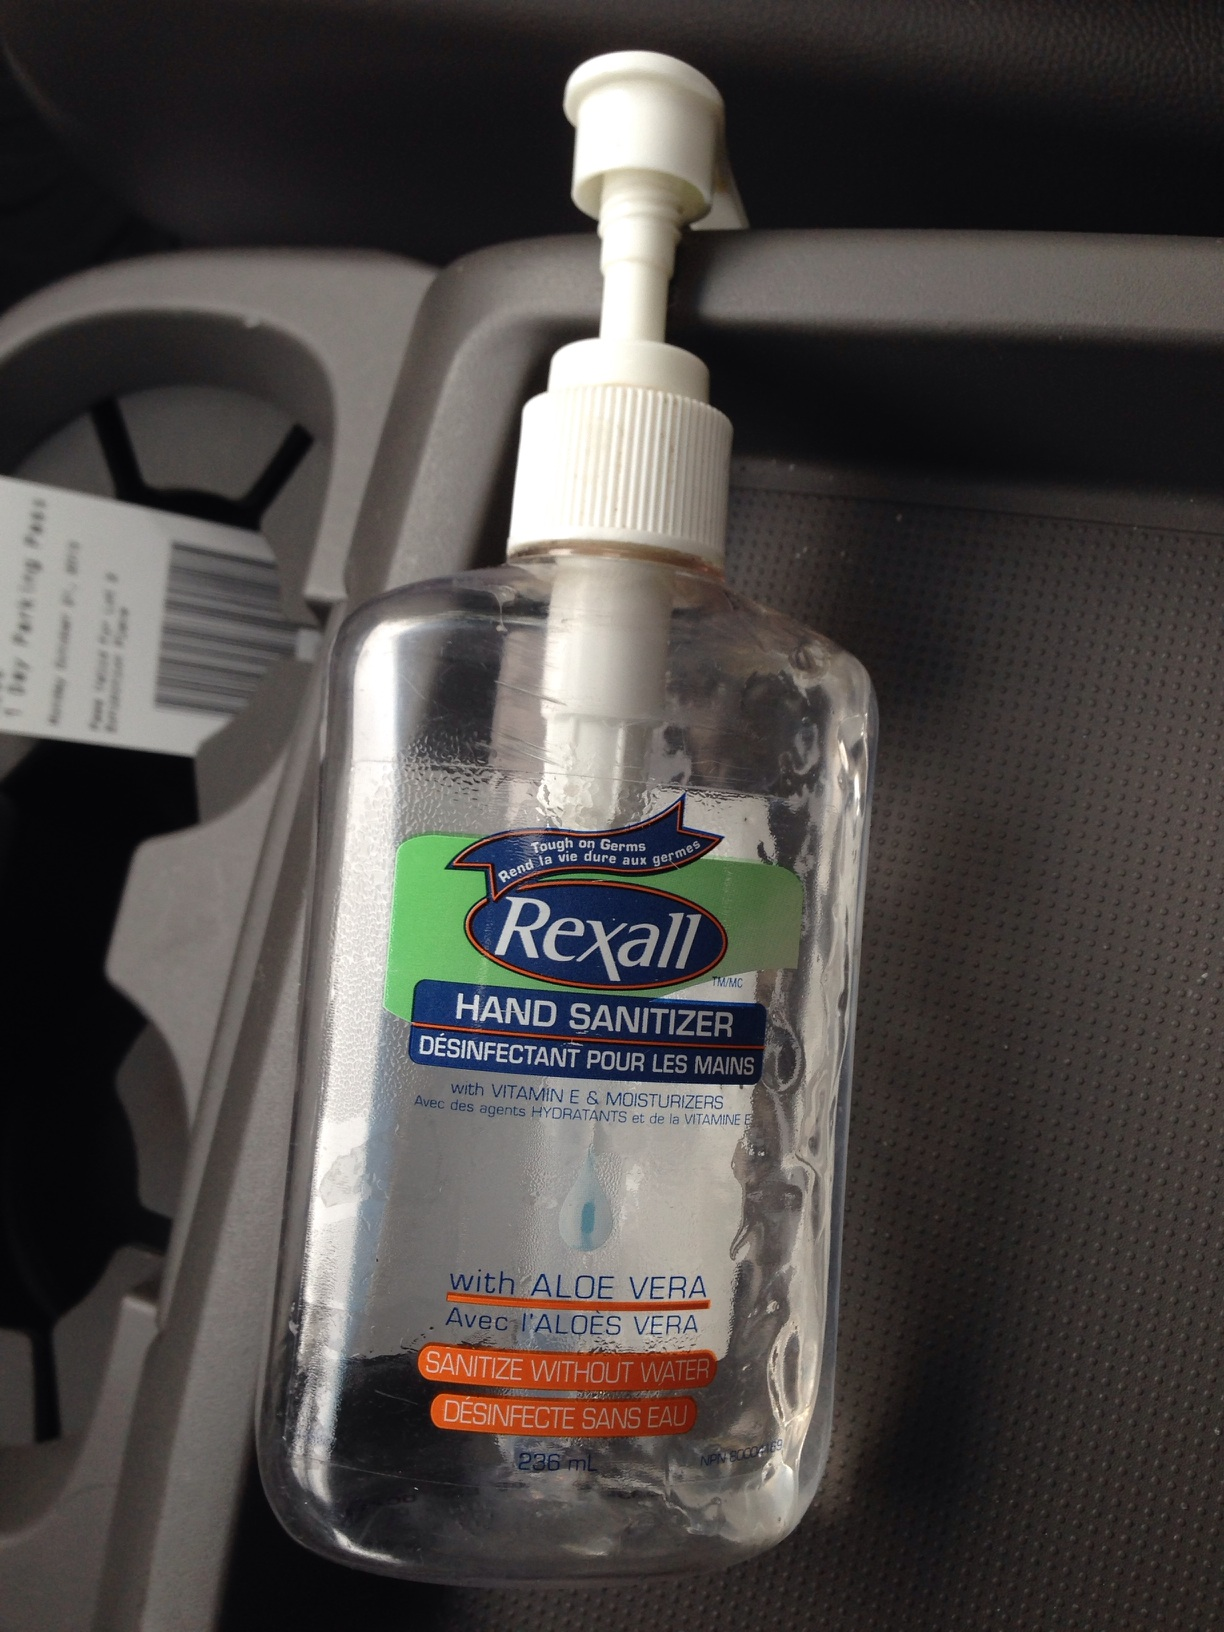What is this bottle? This is a bottle of Rexall hand sanitizer. It is a disinfectant for hands that contains aloe vera and is designed to sanitize without water. The bottle also includes vitamin E and moisturizers to nourish the skin while killing germs effectively. 